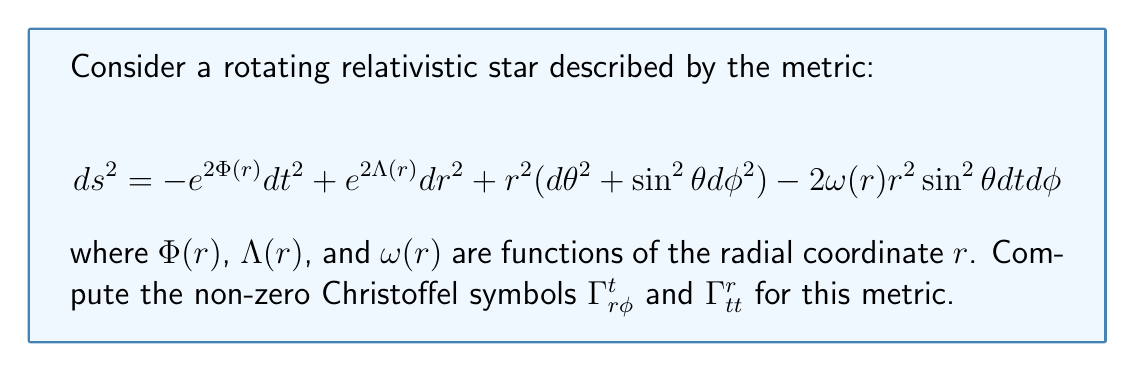Teach me how to tackle this problem. To compute the Christoffel symbols, we'll use the formula:

$$\Gamma^\mu_{\alpha\beta} = \frac{1}{2}g^{\mu\nu}(\partial_\alpha g_{\beta\nu} + \partial_\beta g_{\alpha\nu} - \partial_\nu g_{\alpha\beta})$$

where $g_{\mu\nu}$ is the metric tensor and $g^{\mu\nu}$ is its inverse.

Step 1: Identify the relevant metric components
From the given metric, we have:
$g_{tt} = -e^{2\Phi(r)}$
$g_{rr} = e^{2\Lambda(r)}$
$g_{t\phi} = g_{\phi t} = -\omega(r)r^2\sin^2\theta$

Step 2: Compute $\Gamma^t_{r\phi}$
For $\Gamma^t_{r\phi}$, we need $g^{tt}$ and $\partial_r g_{\phi t}$:

$g^{tt} = -e^{-2\Phi(r)}$
$\partial_r g_{\phi t} = -(\omega'(r)r^2 + 2\omega(r)r)\sin^2\theta$

Therefore,
$$\Gamma^t_{r\phi} = \frac{1}{2}g^{tt}\partial_r g_{\phi t} = \frac{1}{2}e^{-2\Phi(r)}(\omega'(r)r^2 + 2\omega(r)r)\sin^2\theta$$

Step 3: Compute $\Gamma^r_{tt}$
For $\Gamma^r_{tt}$, we need $g^{rr}$ and $\partial_r g_{tt}$:

$g^{rr} = e^{-2\Lambda(r)}$
$\partial_r g_{tt} = -2\Phi'(r)e^{2\Phi(r)}$

Therefore,
$$\Gamma^r_{tt} = \frac{1}{2}g^{rr}\partial_r g_{tt} = -\Phi'(r)e^{2\Phi(r)-2\Lambda(r)}$$

These are the non-zero Christoffel symbols $\Gamma^t_{r\phi}$ and $\Gamma^r_{tt}$ for the given metric.
Answer: $\Gamma^t_{r\phi} = \frac{1}{2}e^{-2\Phi(r)}(\omega'(r)r^2 + 2\omega(r)r)\sin^2\theta$
$\Gamma^r_{tt} = -\Phi'(r)e^{2\Phi(r)-2\Lambda(r)}$ 